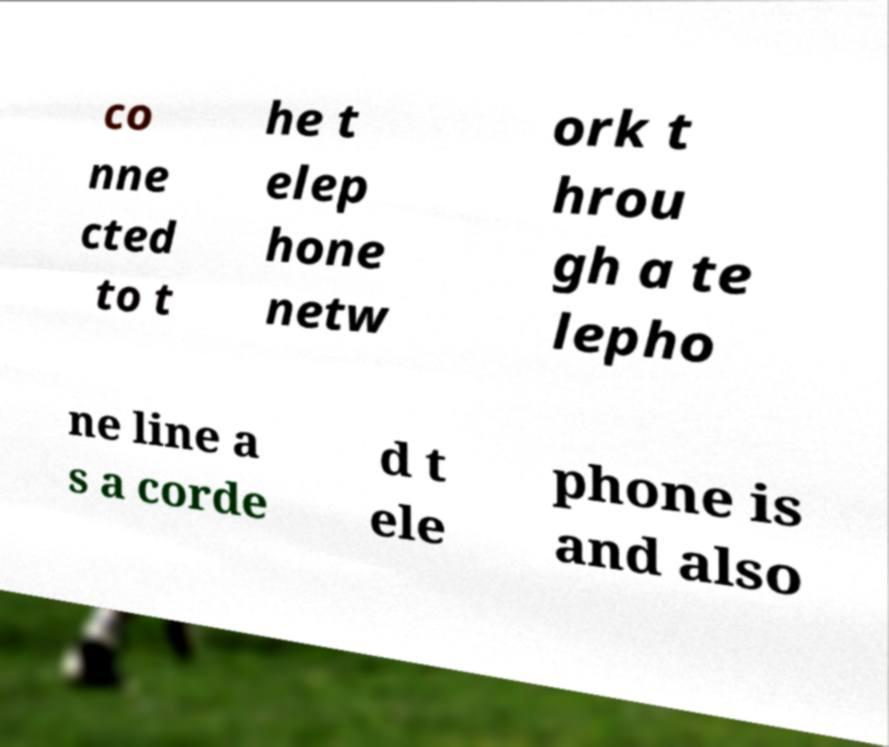Could you assist in decoding the text presented in this image and type it out clearly? co nne cted to t he t elep hone netw ork t hrou gh a te lepho ne line a s a corde d t ele phone is and also 